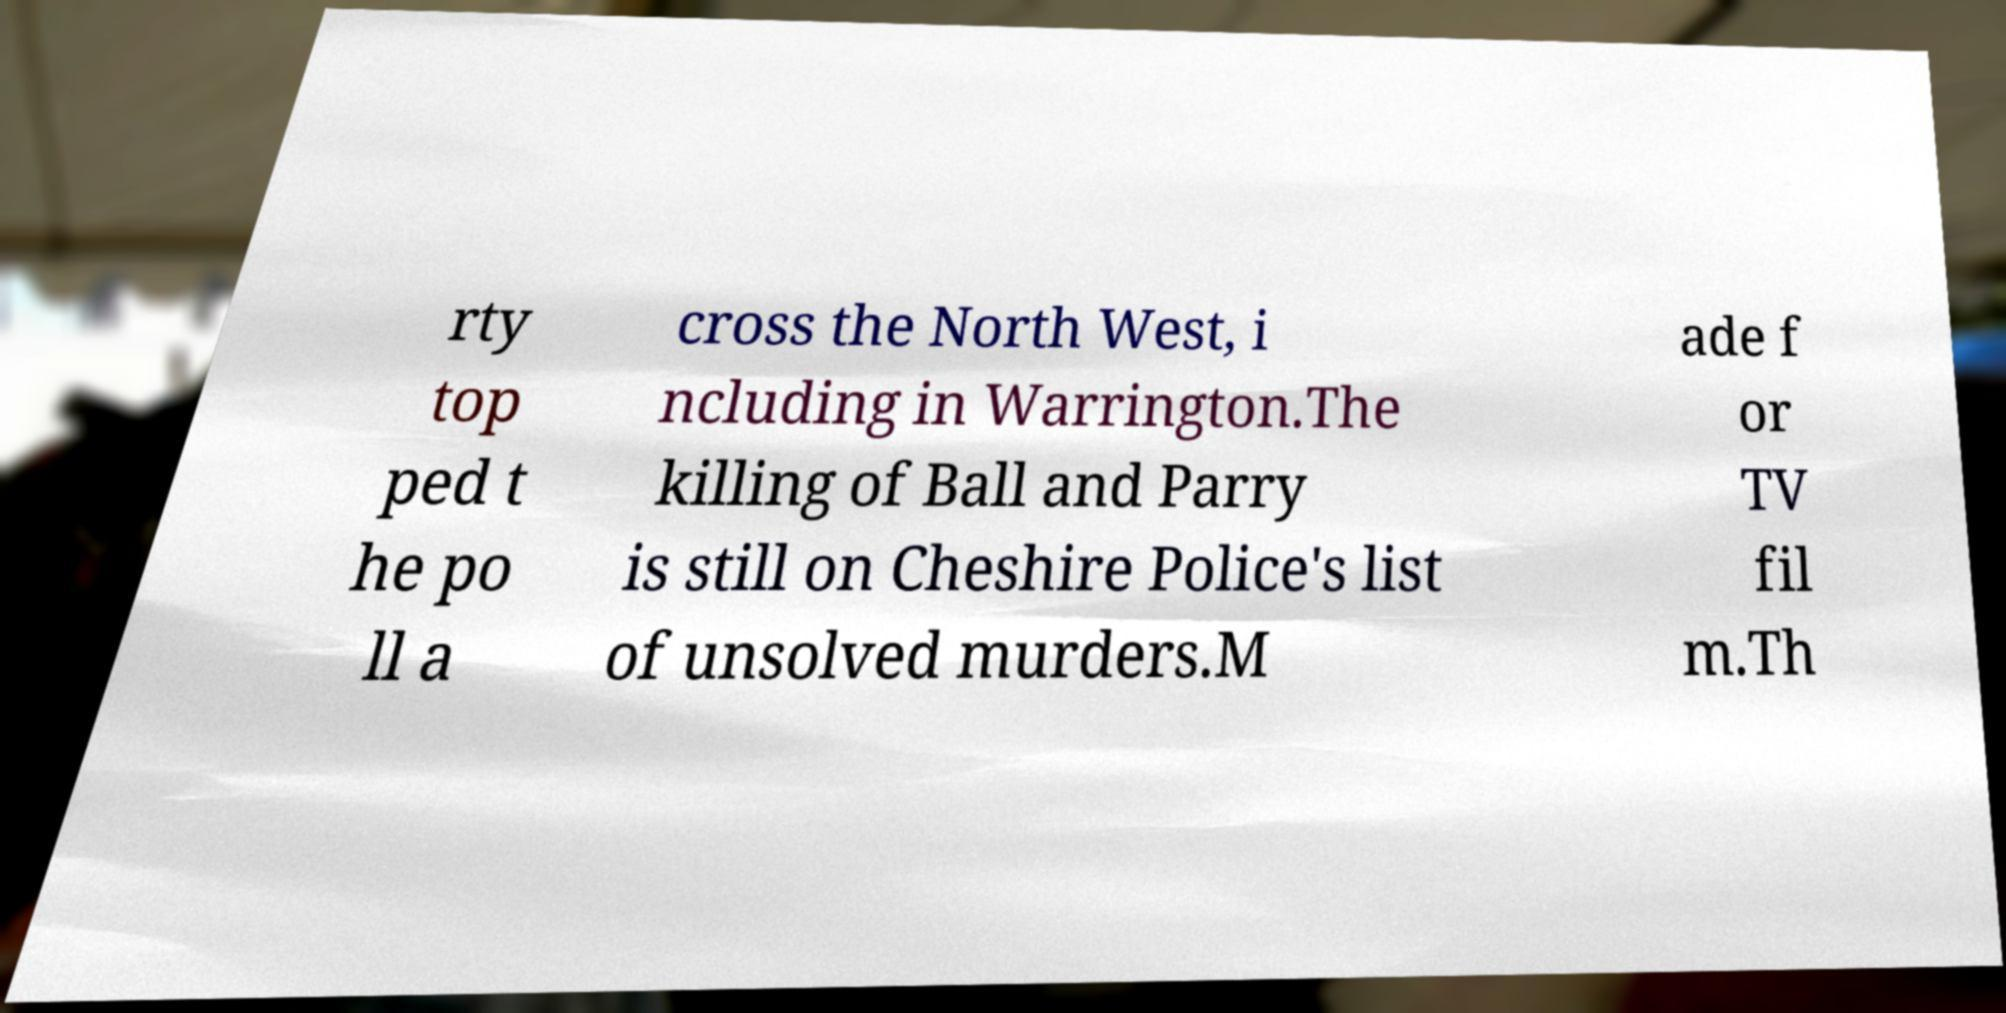I need the written content from this picture converted into text. Can you do that? rty top ped t he po ll a cross the North West, i ncluding in Warrington.The killing of Ball and Parry is still on Cheshire Police's list of unsolved murders.M ade f or TV fil m.Th 